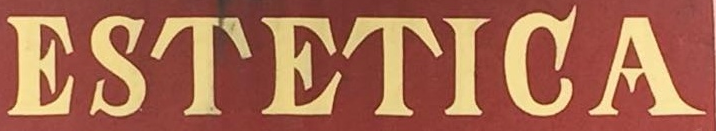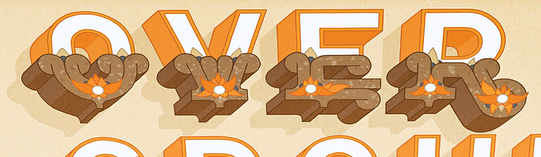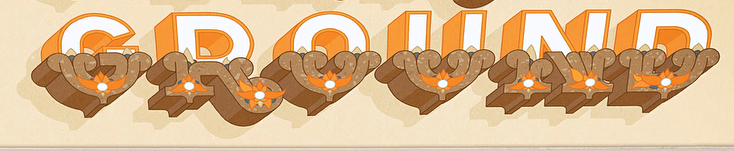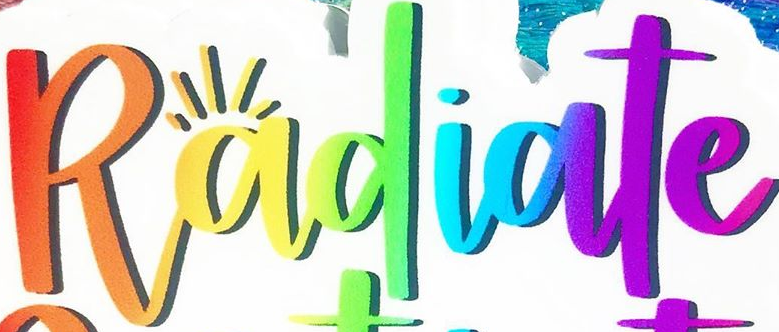Read the text content from these images in order, separated by a semicolon. ESTETIGA; OVER; GROUND; Radiate 